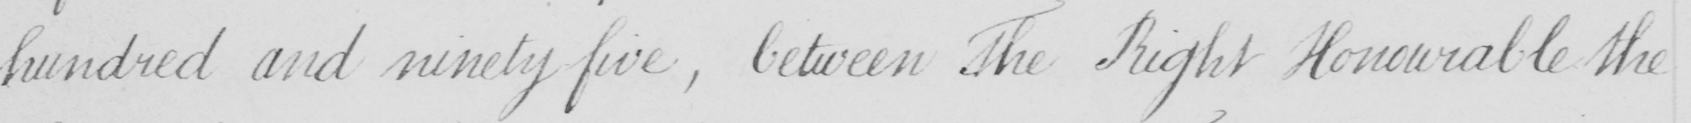What is written in this line of handwriting? hundred and ninety five  , between The Right Honourable the 